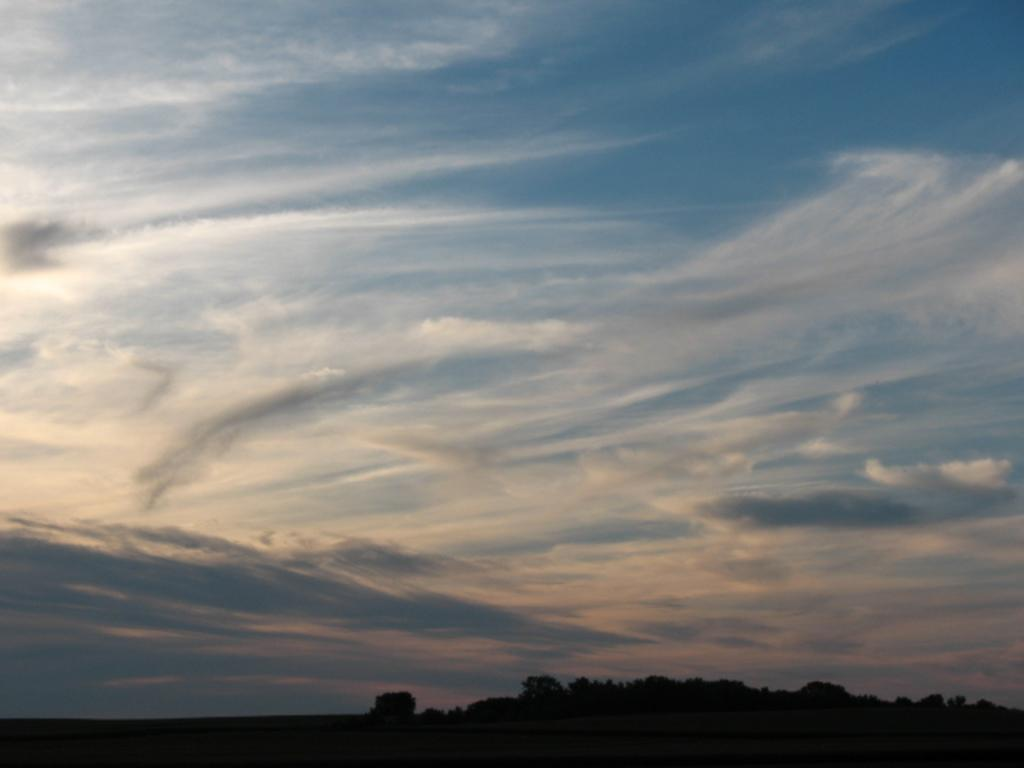What is visible in the sky in the image? The sky with clouds is visible in the image. What type of vegetation can be seen in the image? There are trees in the image. What is the surface visible in the image? The ground is visible in the image. Can you see any steam coming from the trees in the image? There is no steam visible in the image; only clouds in the sky, trees, and the ground are present. How many beads are hanging from the branches of the trees in the image? There are no beads hanging from the branches of the trees in the image; only trees are present. 